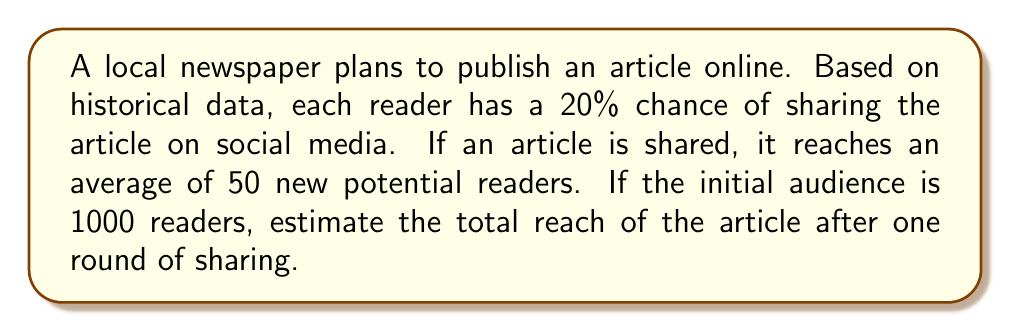Show me your answer to this math problem. Let's approach this step-by-step:

1. Calculate the number of readers who will share the article:
   $$ \text{Sharers} = \text{Initial audience} \times \text{Probability of sharing} $$
   $$ \text{Sharers} = 1000 \times 0.20 = 200 $$

2. Calculate the number of new readers reached through sharing:
   $$ \text{New readers} = \text{Sharers} \times \text{Average new readers per share} $$
   $$ \text{New readers} = 200 \times 50 = 10,000 $$

3. Calculate the total reach by adding the initial audience and new readers:
   $$ \text{Total reach} = \text{Initial audience} + \text{New readers} $$
   $$ \text{Total reach} = 1000 + 10,000 = 11,000 $$

This simulation model demonstrates how social media sharing can significantly amplify the reach of an online article, potentially increasing its audience by a factor of 11 in just one round of sharing.
Answer: 11,000 readers 